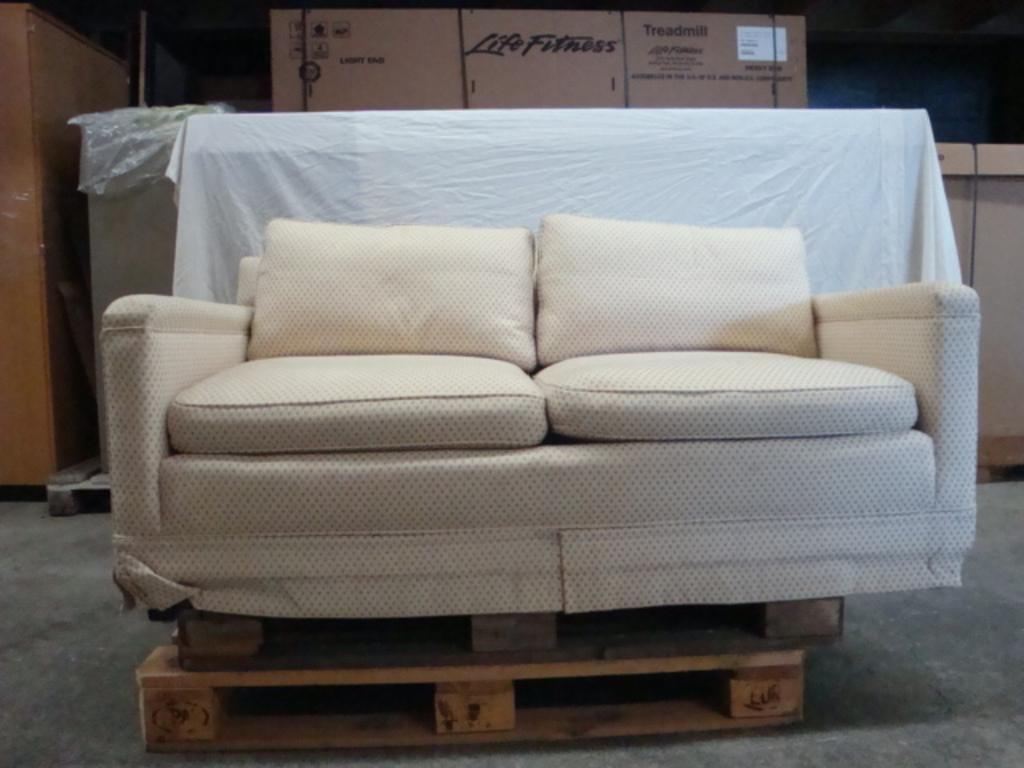What type of furniture is in the image? There is a sofa in the image. What other object can be seen in the image? There is a cardboard box in the image. What type of silver metal is used to make the party decorations in the image? There is no party or decorations present in the image, and therefore no silver metal can be observed. 